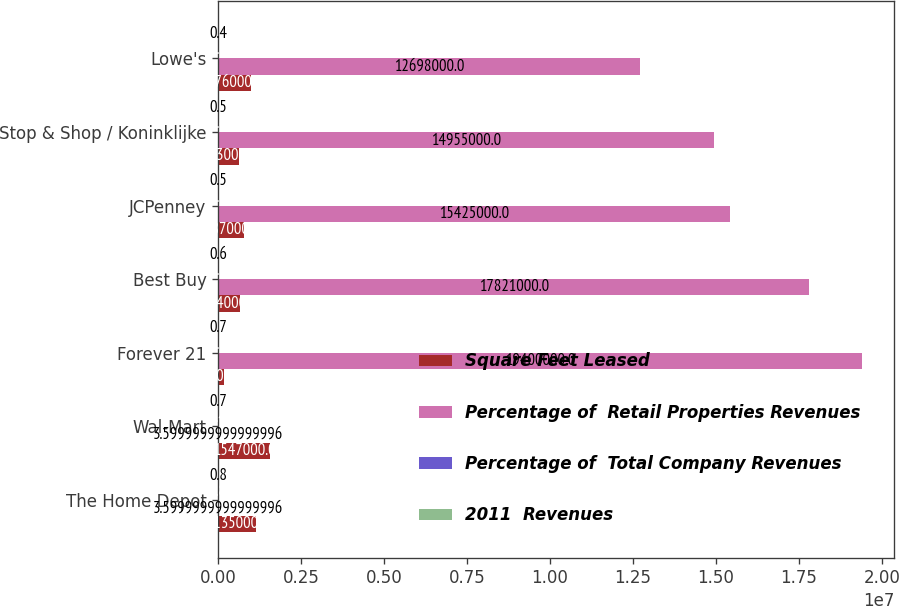Convert chart to OTSL. <chart><loc_0><loc_0><loc_500><loc_500><stacked_bar_chart><ecel><fcel>The Home Depot<fcel>Wal-Mart<fcel>Forever 21<fcel>Best Buy<fcel>JCPenney<fcel>Stop & Shop / Koninklijke<fcel>Lowe's<nl><fcel>Square Feet Leased<fcel>1.135e+06<fcel>1.547e+06<fcel>175000<fcel>664000<fcel>787000<fcel>633000<fcel>976000<nl><fcel>Percentage of  Retail Properties Revenues<fcel>3.6<fcel>3.6<fcel>1.94e+07<fcel>1.7821e+07<fcel>1.5425e+07<fcel>1.4955e+07<fcel>1.2698e+07<nl><fcel>Percentage of  Total Company Revenues<fcel>3.8<fcel>3.4<fcel>3.1<fcel>2.9<fcel>2.5<fcel>2.4<fcel>2<nl><fcel>2011  Revenues<fcel>0.8<fcel>0.7<fcel>0.7<fcel>0.6<fcel>0.5<fcel>0.5<fcel>0.4<nl></chart> 